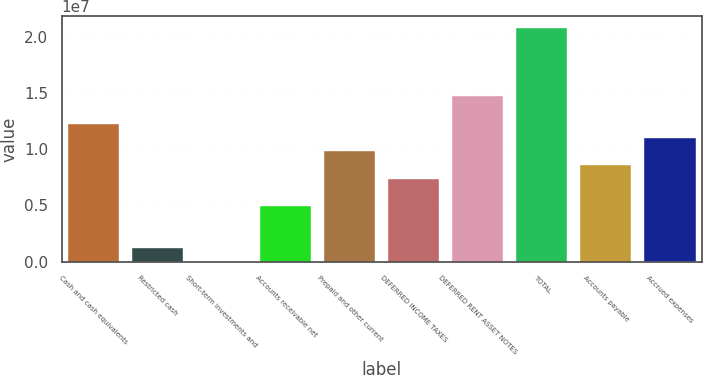Convert chart. <chart><loc_0><loc_0><loc_500><loc_500><bar_chart><fcel>Cash and cash equivalents<fcel>Restricted cash<fcel>Short-term investments and<fcel>Accounts receivable net<fcel>Prepaid and other current<fcel>DEFERRED INCOME TAXES<fcel>DEFERRED RENT ASSET NOTES<fcel>TOTAL<fcel>Accounts payable<fcel>Accrued expenses<nl><fcel>1.22424e+07<fcel>1.24428e+06<fcel>22270<fcel>4.91032e+06<fcel>9.79837e+06<fcel>7.35434e+06<fcel>1.46864e+07<fcel>2.07965e+07<fcel>8.57636e+06<fcel>1.10204e+07<nl></chart> 